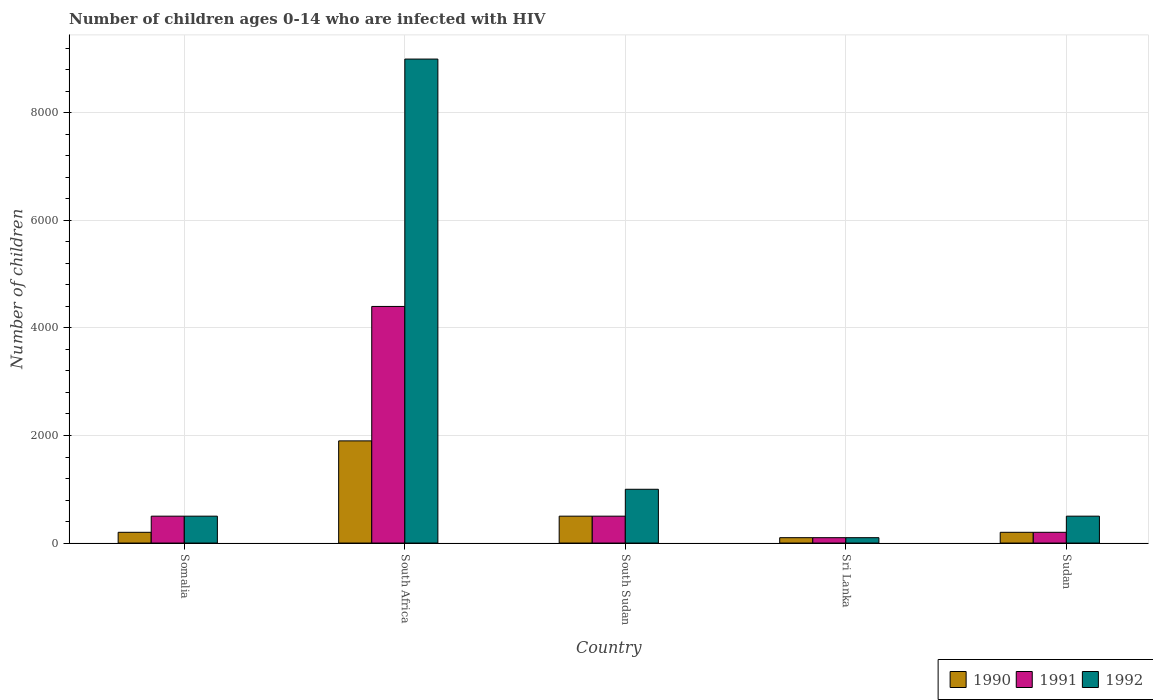Are the number of bars per tick equal to the number of legend labels?
Offer a terse response. Yes. How many bars are there on the 1st tick from the right?
Offer a terse response. 3. What is the label of the 2nd group of bars from the left?
Provide a succinct answer. South Africa. In how many cases, is the number of bars for a given country not equal to the number of legend labels?
Give a very brief answer. 0. What is the number of HIV infected children in 1990 in South Sudan?
Your answer should be compact. 500. Across all countries, what is the maximum number of HIV infected children in 1990?
Ensure brevity in your answer.  1900. Across all countries, what is the minimum number of HIV infected children in 1991?
Provide a short and direct response. 100. In which country was the number of HIV infected children in 1990 maximum?
Your answer should be compact. South Africa. In which country was the number of HIV infected children in 1991 minimum?
Your response must be concise. Sri Lanka. What is the total number of HIV infected children in 1990 in the graph?
Make the answer very short. 2900. What is the difference between the number of HIV infected children in 1991 in South Africa and that in Sri Lanka?
Make the answer very short. 4300. What is the difference between the number of HIV infected children in 1992 in Somalia and the number of HIV infected children in 1991 in Sri Lanka?
Give a very brief answer. 400. What is the average number of HIV infected children in 1991 per country?
Offer a very short reply. 1140. What is the difference between the number of HIV infected children of/in 1992 and number of HIV infected children of/in 1990 in South Africa?
Provide a succinct answer. 7100. Is the number of HIV infected children in 1991 in Sri Lanka less than that in Sudan?
Your response must be concise. Yes. Is the difference between the number of HIV infected children in 1992 in Somalia and Sudan greater than the difference between the number of HIV infected children in 1990 in Somalia and Sudan?
Offer a terse response. No. What is the difference between the highest and the second highest number of HIV infected children in 1992?
Provide a succinct answer. 8000. What is the difference between the highest and the lowest number of HIV infected children in 1992?
Your answer should be compact. 8900. What does the 1st bar from the left in Somalia represents?
Your response must be concise. 1990. What does the 2nd bar from the right in South Africa represents?
Ensure brevity in your answer.  1991. Is it the case that in every country, the sum of the number of HIV infected children in 1992 and number of HIV infected children in 1990 is greater than the number of HIV infected children in 1991?
Your answer should be very brief. Yes. How many bars are there?
Make the answer very short. 15. Are all the bars in the graph horizontal?
Offer a terse response. No. What is the difference between two consecutive major ticks on the Y-axis?
Ensure brevity in your answer.  2000. Are the values on the major ticks of Y-axis written in scientific E-notation?
Keep it short and to the point. No. Does the graph contain any zero values?
Offer a very short reply. No. Does the graph contain grids?
Make the answer very short. Yes. Where does the legend appear in the graph?
Your answer should be compact. Bottom right. What is the title of the graph?
Make the answer very short. Number of children ages 0-14 who are infected with HIV. Does "1972" appear as one of the legend labels in the graph?
Give a very brief answer. No. What is the label or title of the Y-axis?
Your response must be concise. Number of children. What is the Number of children in 1992 in Somalia?
Give a very brief answer. 500. What is the Number of children of 1990 in South Africa?
Your answer should be very brief. 1900. What is the Number of children of 1991 in South Africa?
Keep it short and to the point. 4400. What is the Number of children in 1992 in South Africa?
Provide a short and direct response. 9000. What is the Number of children of 1990 in South Sudan?
Make the answer very short. 500. What is the Number of children of 1991 in South Sudan?
Your answer should be very brief. 500. What is the Number of children in 1990 in Sri Lanka?
Provide a short and direct response. 100. What is the Number of children of 1991 in Sri Lanka?
Offer a terse response. 100. What is the Number of children of 1992 in Sri Lanka?
Offer a very short reply. 100. What is the Number of children of 1991 in Sudan?
Provide a succinct answer. 200. Across all countries, what is the maximum Number of children of 1990?
Your answer should be compact. 1900. Across all countries, what is the maximum Number of children of 1991?
Give a very brief answer. 4400. Across all countries, what is the maximum Number of children in 1992?
Offer a terse response. 9000. Across all countries, what is the minimum Number of children in 1992?
Offer a very short reply. 100. What is the total Number of children of 1990 in the graph?
Provide a short and direct response. 2900. What is the total Number of children in 1991 in the graph?
Your answer should be very brief. 5700. What is the total Number of children of 1992 in the graph?
Give a very brief answer. 1.11e+04. What is the difference between the Number of children in 1990 in Somalia and that in South Africa?
Make the answer very short. -1700. What is the difference between the Number of children of 1991 in Somalia and that in South Africa?
Your answer should be compact. -3900. What is the difference between the Number of children of 1992 in Somalia and that in South Africa?
Offer a very short reply. -8500. What is the difference between the Number of children of 1990 in Somalia and that in South Sudan?
Provide a short and direct response. -300. What is the difference between the Number of children in 1991 in Somalia and that in South Sudan?
Your response must be concise. 0. What is the difference between the Number of children of 1992 in Somalia and that in South Sudan?
Offer a terse response. -500. What is the difference between the Number of children of 1990 in Somalia and that in Sri Lanka?
Your answer should be very brief. 100. What is the difference between the Number of children of 1991 in Somalia and that in Sri Lanka?
Keep it short and to the point. 400. What is the difference between the Number of children in 1990 in Somalia and that in Sudan?
Keep it short and to the point. 0. What is the difference between the Number of children of 1991 in Somalia and that in Sudan?
Your response must be concise. 300. What is the difference between the Number of children in 1992 in Somalia and that in Sudan?
Your answer should be compact. 0. What is the difference between the Number of children of 1990 in South Africa and that in South Sudan?
Your answer should be compact. 1400. What is the difference between the Number of children of 1991 in South Africa and that in South Sudan?
Ensure brevity in your answer.  3900. What is the difference between the Number of children of 1992 in South Africa and that in South Sudan?
Ensure brevity in your answer.  8000. What is the difference between the Number of children of 1990 in South Africa and that in Sri Lanka?
Keep it short and to the point. 1800. What is the difference between the Number of children in 1991 in South Africa and that in Sri Lanka?
Your answer should be very brief. 4300. What is the difference between the Number of children of 1992 in South Africa and that in Sri Lanka?
Your answer should be compact. 8900. What is the difference between the Number of children in 1990 in South Africa and that in Sudan?
Your response must be concise. 1700. What is the difference between the Number of children in 1991 in South Africa and that in Sudan?
Make the answer very short. 4200. What is the difference between the Number of children in 1992 in South Africa and that in Sudan?
Provide a short and direct response. 8500. What is the difference between the Number of children in 1990 in South Sudan and that in Sri Lanka?
Make the answer very short. 400. What is the difference between the Number of children of 1991 in South Sudan and that in Sri Lanka?
Make the answer very short. 400. What is the difference between the Number of children of 1992 in South Sudan and that in Sri Lanka?
Your answer should be compact. 900. What is the difference between the Number of children of 1990 in South Sudan and that in Sudan?
Your response must be concise. 300. What is the difference between the Number of children of 1991 in South Sudan and that in Sudan?
Ensure brevity in your answer.  300. What is the difference between the Number of children of 1992 in South Sudan and that in Sudan?
Your answer should be very brief. 500. What is the difference between the Number of children in 1990 in Sri Lanka and that in Sudan?
Provide a short and direct response. -100. What is the difference between the Number of children of 1991 in Sri Lanka and that in Sudan?
Ensure brevity in your answer.  -100. What is the difference between the Number of children in 1992 in Sri Lanka and that in Sudan?
Offer a terse response. -400. What is the difference between the Number of children of 1990 in Somalia and the Number of children of 1991 in South Africa?
Offer a very short reply. -4200. What is the difference between the Number of children in 1990 in Somalia and the Number of children in 1992 in South Africa?
Provide a succinct answer. -8800. What is the difference between the Number of children in 1991 in Somalia and the Number of children in 1992 in South Africa?
Offer a very short reply. -8500. What is the difference between the Number of children in 1990 in Somalia and the Number of children in 1991 in South Sudan?
Give a very brief answer. -300. What is the difference between the Number of children in 1990 in Somalia and the Number of children in 1992 in South Sudan?
Your response must be concise. -800. What is the difference between the Number of children of 1991 in Somalia and the Number of children of 1992 in South Sudan?
Your answer should be very brief. -500. What is the difference between the Number of children in 1990 in Somalia and the Number of children in 1992 in Sri Lanka?
Your response must be concise. 100. What is the difference between the Number of children of 1990 in Somalia and the Number of children of 1992 in Sudan?
Offer a very short reply. -300. What is the difference between the Number of children of 1990 in South Africa and the Number of children of 1991 in South Sudan?
Offer a terse response. 1400. What is the difference between the Number of children in 1990 in South Africa and the Number of children in 1992 in South Sudan?
Ensure brevity in your answer.  900. What is the difference between the Number of children in 1991 in South Africa and the Number of children in 1992 in South Sudan?
Ensure brevity in your answer.  3400. What is the difference between the Number of children of 1990 in South Africa and the Number of children of 1991 in Sri Lanka?
Provide a succinct answer. 1800. What is the difference between the Number of children of 1990 in South Africa and the Number of children of 1992 in Sri Lanka?
Provide a succinct answer. 1800. What is the difference between the Number of children in 1991 in South Africa and the Number of children in 1992 in Sri Lanka?
Make the answer very short. 4300. What is the difference between the Number of children of 1990 in South Africa and the Number of children of 1991 in Sudan?
Your answer should be compact. 1700. What is the difference between the Number of children of 1990 in South Africa and the Number of children of 1992 in Sudan?
Offer a terse response. 1400. What is the difference between the Number of children in 1991 in South Africa and the Number of children in 1992 in Sudan?
Ensure brevity in your answer.  3900. What is the difference between the Number of children in 1990 in South Sudan and the Number of children in 1991 in Sudan?
Provide a short and direct response. 300. What is the difference between the Number of children in 1990 in South Sudan and the Number of children in 1992 in Sudan?
Offer a very short reply. 0. What is the difference between the Number of children of 1990 in Sri Lanka and the Number of children of 1991 in Sudan?
Your response must be concise. -100. What is the difference between the Number of children of 1990 in Sri Lanka and the Number of children of 1992 in Sudan?
Your response must be concise. -400. What is the difference between the Number of children of 1991 in Sri Lanka and the Number of children of 1992 in Sudan?
Give a very brief answer. -400. What is the average Number of children of 1990 per country?
Make the answer very short. 580. What is the average Number of children of 1991 per country?
Provide a short and direct response. 1140. What is the average Number of children of 1992 per country?
Give a very brief answer. 2220. What is the difference between the Number of children of 1990 and Number of children of 1991 in Somalia?
Provide a short and direct response. -300. What is the difference between the Number of children in 1990 and Number of children in 1992 in Somalia?
Make the answer very short. -300. What is the difference between the Number of children in 1990 and Number of children in 1991 in South Africa?
Give a very brief answer. -2500. What is the difference between the Number of children in 1990 and Number of children in 1992 in South Africa?
Provide a succinct answer. -7100. What is the difference between the Number of children of 1991 and Number of children of 1992 in South Africa?
Ensure brevity in your answer.  -4600. What is the difference between the Number of children in 1990 and Number of children in 1991 in South Sudan?
Offer a terse response. 0. What is the difference between the Number of children in 1990 and Number of children in 1992 in South Sudan?
Offer a very short reply. -500. What is the difference between the Number of children in 1991 and Number of children in 1992 in South Sudan?
Your response must be concise. -500. What is the difference between the Number of children of 1991 and Number of children of 1992 in Sri Lanka?
Offer a very short reply. 0. What is the difference between the Number of children in 1990 and Number of children in 1991 in Sudan?
Keep it short and to the point. 0. What is the difference between the Number of children of 1990 and Number of children of 1992 in Sudan?
Offer a very short reply. -300. What is the difference between the Number of children in 1991 and Number of children in 1992 in Sudan?
Your answer should be very brief. -300. What is the ratio of the Number of children in 1990 in Somalia to that in South Africa?
Your answer should be compact. 0.11. What is the ratio of the Number of children of 1991 in Somalia to that in South Africa?
Make the answer very short. 0.11. What is the ratio of the Number of children in 1992 in Somalia to that in South Africa?
Your answer should be compact. 0.06. What is the ratio of the Number of children in 1991 in Somalia to that in Sri Lanka?
Provide a succinct answer. 5. What is the ratio of the Number of children of 1991 in South Africa to that in South Sudan?
Give a very brief answer. 8.8. What is the ratio of the Number of children of 1991 in South Africa to that in Sri Lanka?
Your answer should be very brief. 44. What is the ratio of the Number of children in 1992 in South Africa to that in Sri Lanka?
Your answer should be very brief. 90. What is the ratio of the Number of children of 1990 in South Africa to that in Sudan?
Give a very brief answer. 9.5. What is the ratio of the Number of children of 1991 in South Africa to that in Sudan?
Your response must be concise. 22. What is the ratio of the Number of children in 1992 in South Africa to that in Sudan?
Offer a very short reply. 18. What is the ratio of the Number of children in 1990 in South Sudan to that in Sri Lanka?
Provide a short and direct response. 5. What is the ratio of the Number of children in 1991 in South Sudan to that in Sri Lanka?
Offer a terse response. 5. What is the ratio of the Number of children of 1990 in South Sudan to that in Sudan?
Provide a succinct answer. 2.5. What is the ratio of the Number of children in 1991 in Sri Lanka to that in Sudan?
Ensure brevity in your answer.  0.5. What is the difference between the highest and the second highest Number of children of 1990?
Your response must be concise. 1400. What is the difference between the highest and the second highest Number of children in 1991?
Give a very brief answer. 3900. What is the difference between the highest and the second highest Number of children in 1992?
Make the answer very short. 8000. What is the difference between the highest and the lowest Number of children in 1990?
Your answer should be compact. 1800. What is the difference between the highest and the lowest Number of children of 1991?
Offer a terse response. 4300. What is the difference between the highest and the lowest Number of children of 1992?
Your response must be concise. 8900. 